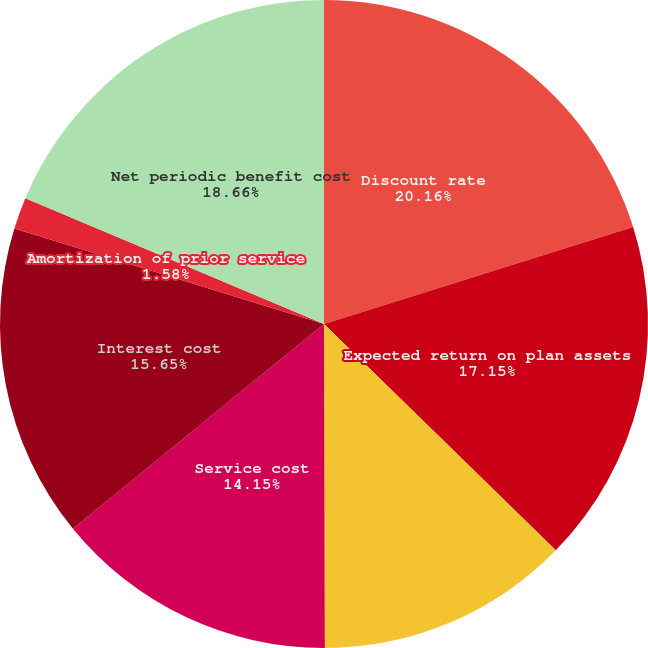Convert chart. <chart><loc_0><loc_0><loc_500><loc_500><pie_chart><fcel>Discount rate<fcel>Expected return on plan assets<fcel>Rate of compensation increase<fcel>Service cost<fcel>Interest cost<fcel>Amortization of prior service<fcel>Net periodic benefit cost<nl><fcel>20.16%<fcel>17.15%<fcel>12.65%<fcel>14.15%<fcel>15.65%<fcel>1.58%<fcel>18.66%<nl></chart> 